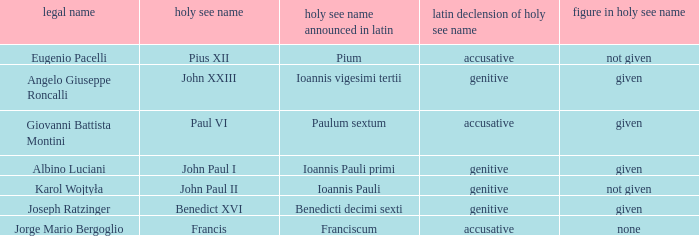For Pope Paul VI, what is the declension of his papal name? Accusative. 